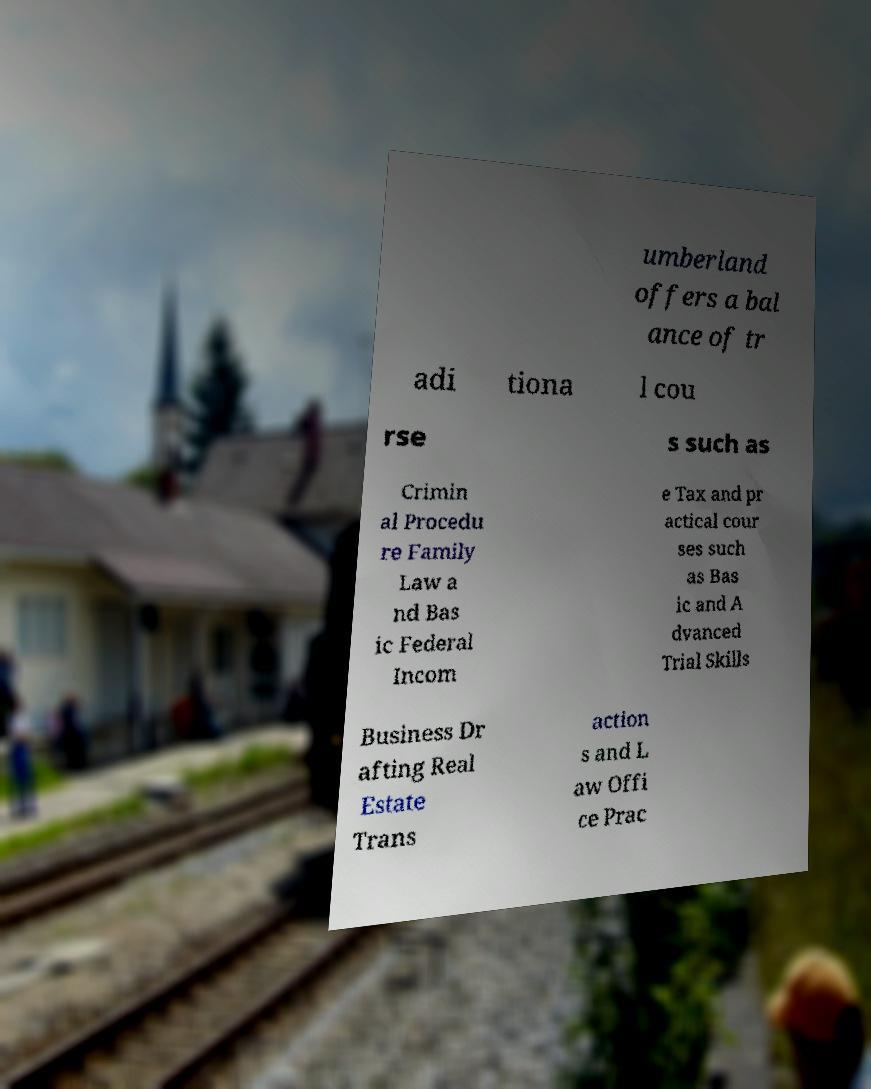Could you extract and type out the text from this image? umberland offers a bal ance of tr adi tiona l cou rse s such as Crimin al Procedu re Family Law a nd Bas ic Federal Incom e Tax and pr actical cour ses such as Bas ic and A dvanced Trial Skills Business Dr afting Real Estate Trans action s and L aw Offi ce Prac 